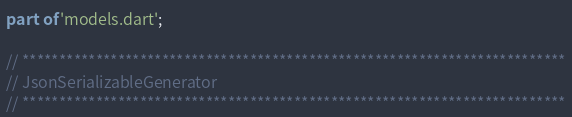<code> <loc_0><loc_0><loc_500><loc_500><_Dart_>part of 'models.dart';

// **************************************************************************
// JsonSerializableGenerator
// **************************************************************************
</code> 